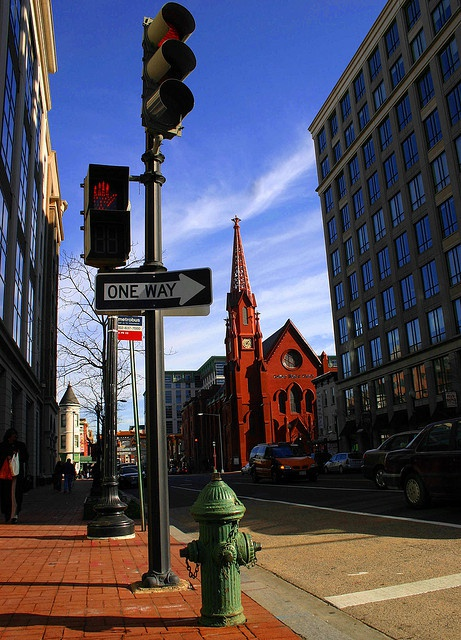Describe the objects in this image and their specific colors. I can see fire hydrant in black, olive, and darkgreen tones, traffic light in black, lightblue, and olive tones, traffic light in black, olive, maroon, and gray tones, car in black, gray, and darkgreen tones, and car in black, maroon, gray, and navy tones in this image. 